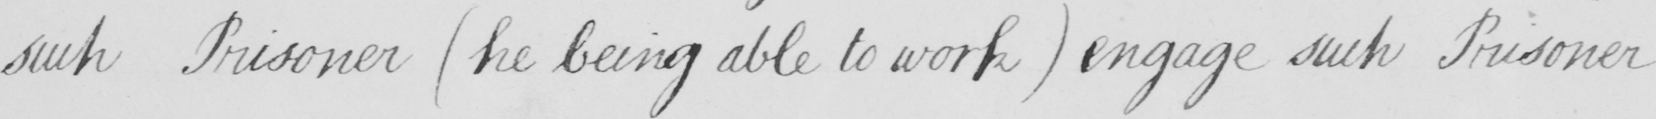Please provide the text content of this handwritten line. such Prisoner  ( he being able to work )  engage such Prisoner 